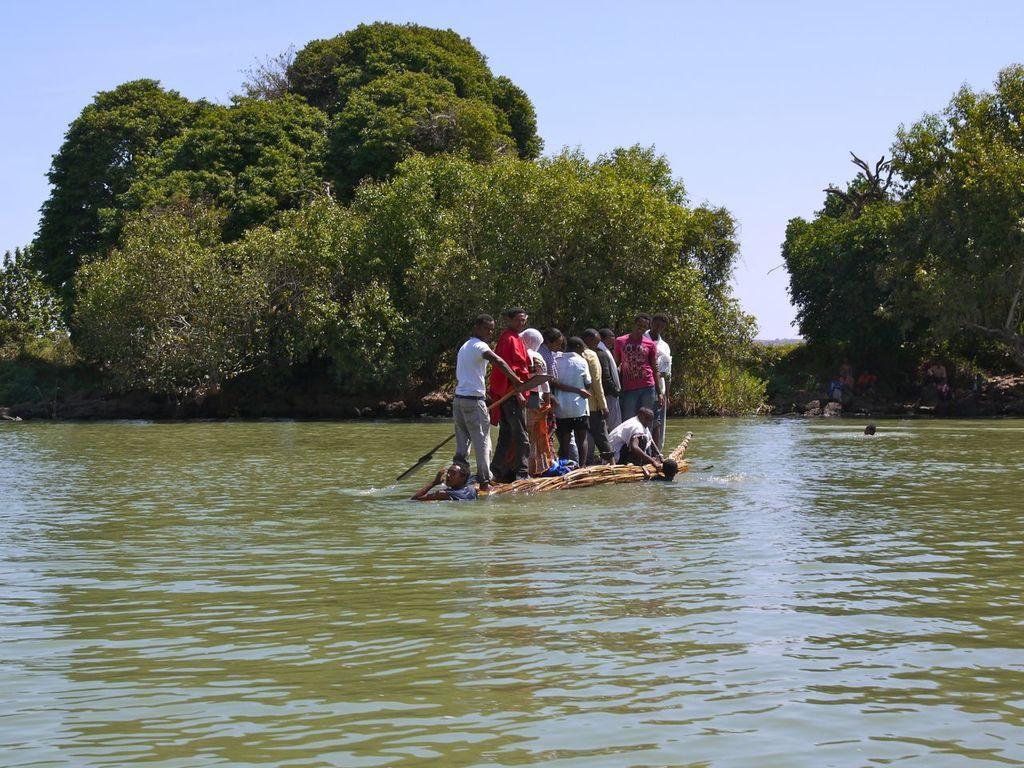Please provide a concise description of this image. This is a picture taken near a river or a lake. In the foreground of the picture there are water, in the water there are few persons standing on a wood. In the background there are trees. Sky is clear and Sunny. 